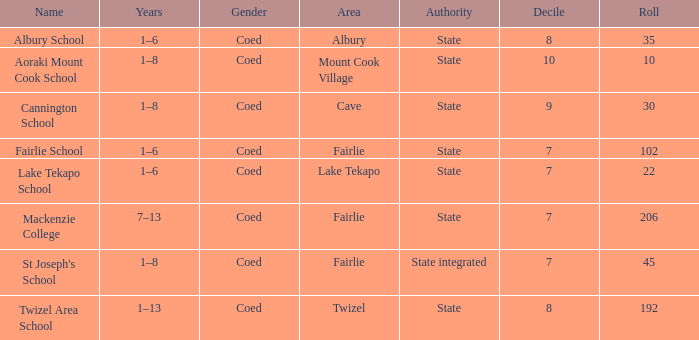What area is named Mackenzie college? Fairlie. 